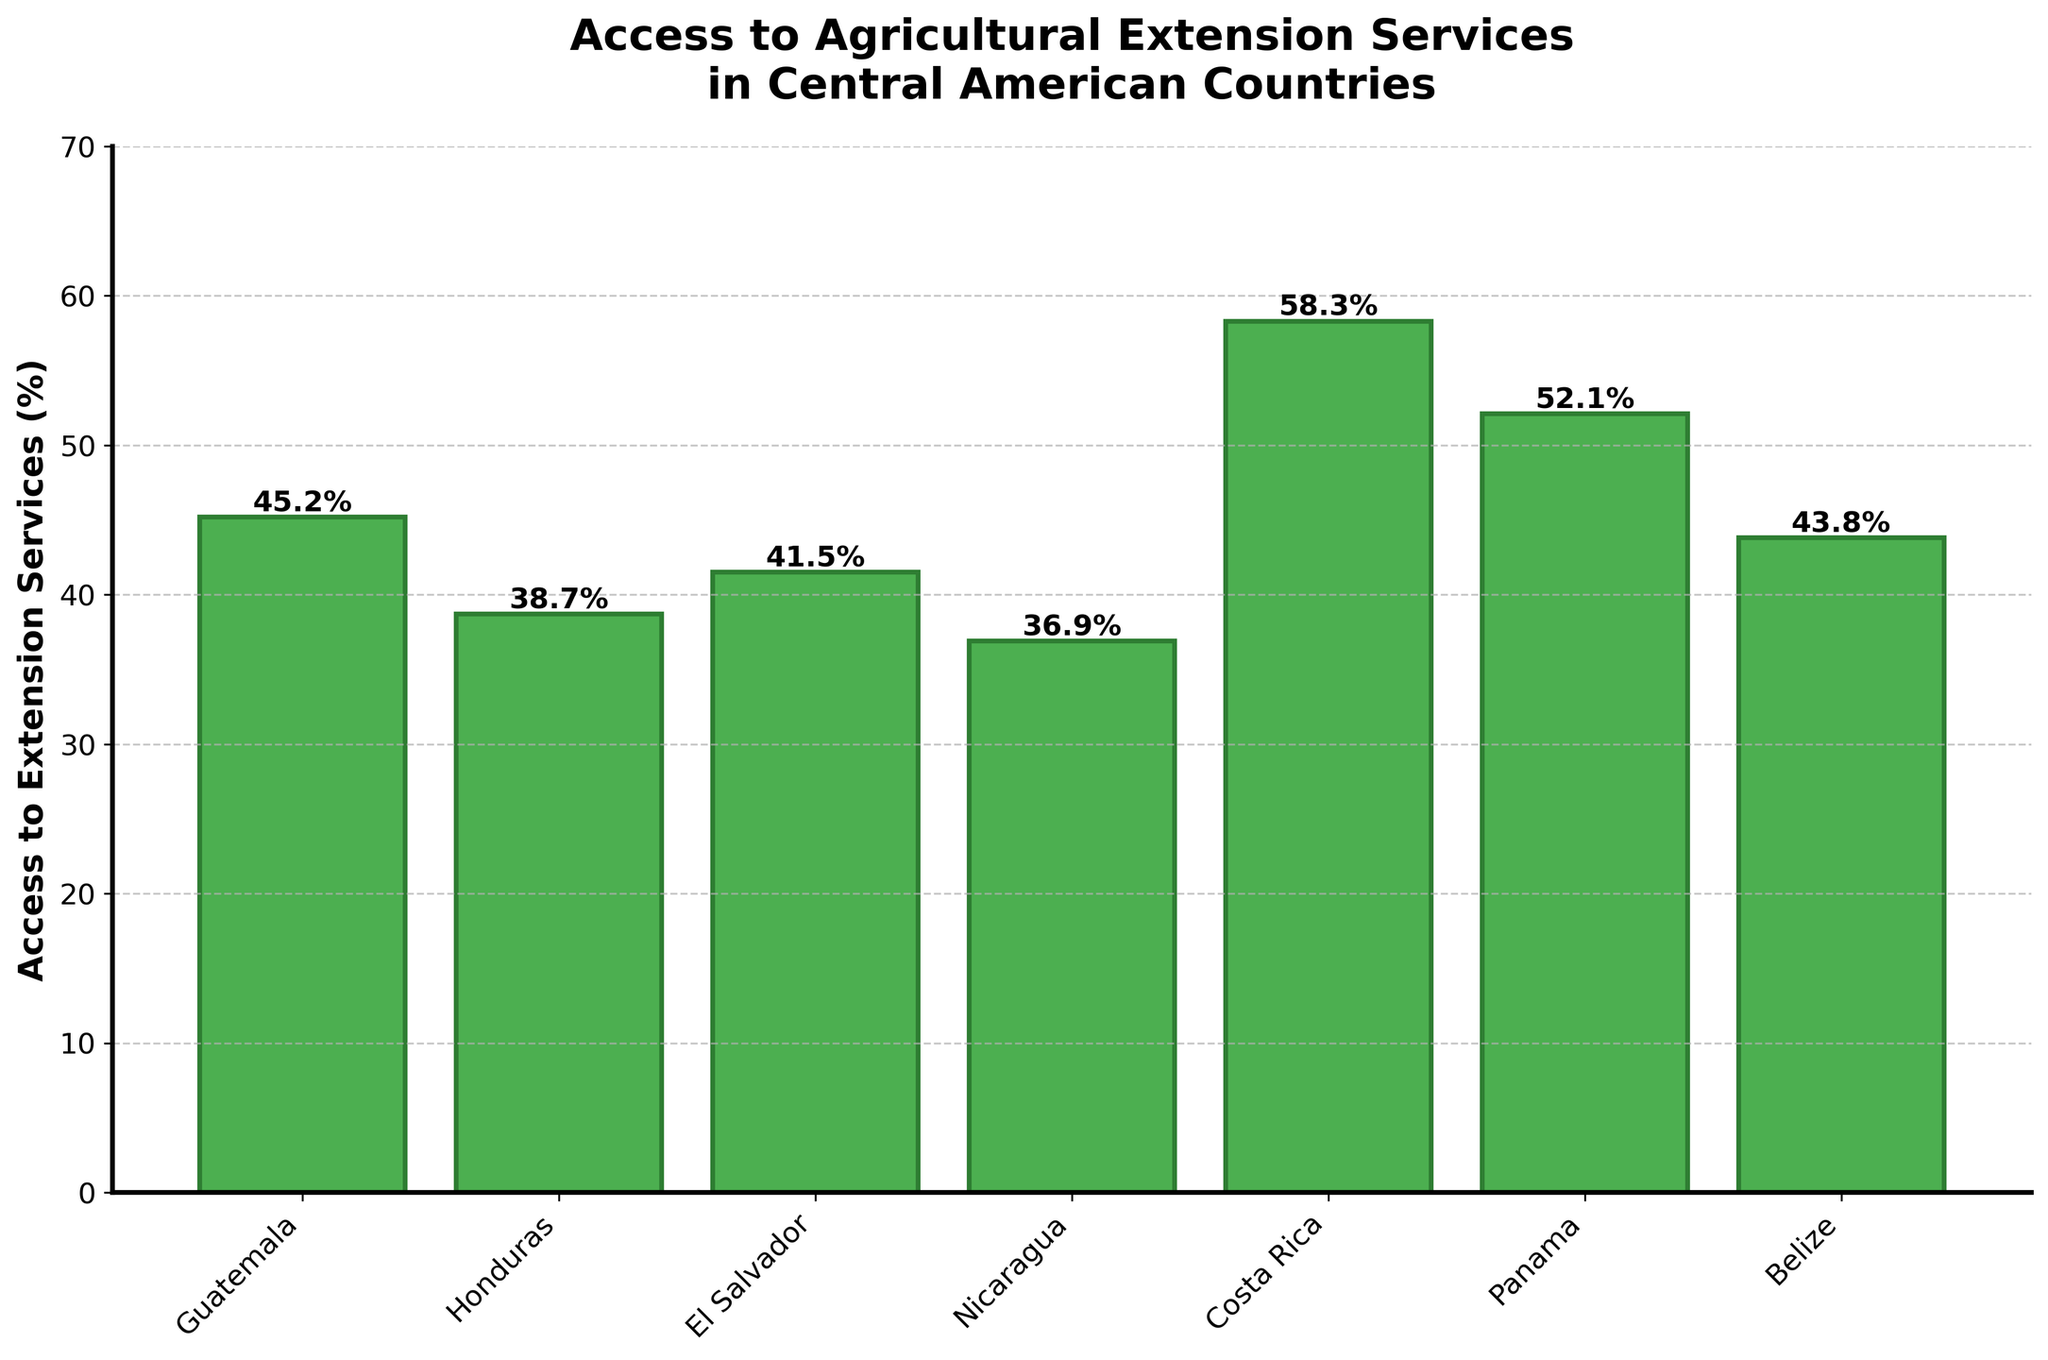What percentage of rural communities in Guatemala have access to agricultural extension services? Refer to the bar height for Guatemala, which is clearly labeled above the bar. It reads 45.2%.
Answer: 45.2% Which country has the highest percentage of access to agricultural extension services? Look at all the bars and identify the tallest one. The bar for Costa Rica is the tallest, with a percentage of 58.3%.
Answer: Costa Rica How much higher is the percentage of access to extension services in Costa Rica compared to Honduras? The percentage for Costa Rica is 58.3%, and for Honduras, it's 38.7%. The difference is 58.3 - 38.7 = 19.6%.
Answer: 19.6% Which two countries have almost similar access to agricultural extension services, with a difference of less than 3%? Compare the heights of the bars and find Belize (43.8%) and Guatemala (45.2%). The difference is 45.2 - 43.8 = 1.4%.
Answer: Belize and Guatemala What is the average percentage of access to agricultural extension services in Nicaragua and Panama? Add the percentages of Nicaragua (36.9%) and Panama (52.1%) and then divide by 2. The calculation is (36.9 + 52.1)/2 = 44.5%.
Answer: 44.5% Which country has a lower percentage of access to agricultural extension services, El Salvador or Panama? Compare the bar heights for El Salvador and Panama. El Salvador is at 41.5%, and Panama is at 52.1%. Therefore, El Salvador has the lower percentage.
Answer: El Salvador Is there any country with access to extension services below 40%? If so, name them. Visually inspect the bar chart for bars below the 40% mark. Nicaragua (36.9%) and Honduras (38.7%) are below 40%.
Answer: Nicaragua and Honduras What is the difference in agricultural extension service access between Guatemala and Costa Rica? Subtract the percentage of Guatemala (45.2%) from Costa Rica (58.3%). The difference is 58.3 - 45.2 = 13.1%.
Answer: 13.1% Which countries have a higher percentage of access to extension services than the average value of all countries listed? First, calculate the average: \\((45.2 + 38.7 + 41.5 + 36.9 + 58.3 + 52.1 + 43.8) / 7 = 45.21%\\). Countries above this average are Costa Rica (58.3%), Panama (52.1%).
Answer: Costa Rica, Panama What is the combined percentage of access to agricultural extension services for countries with over 50% access? Sum the percentages of Costa Rica (58.3%) and Panama (52.1%). The combined percentage is 58.3 + 52.1 = 110.4%.
Answer: 110.4% 